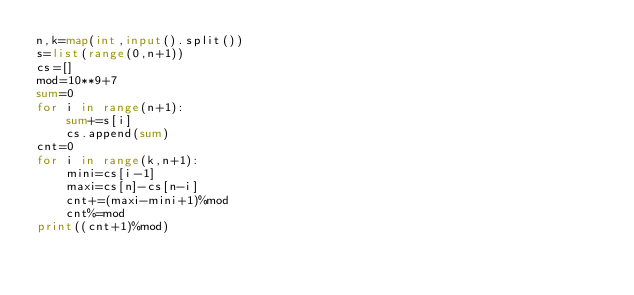<code> <loc_0><loc_0><loc_500><loc_500><_Python_>n,k=map(int,input().split())
s=list(range(0,n+1))
cs=[]
mod=10**9+7
sum=0
for i in range(n+1):
	sum+=s[i]
	cs.append(sum)
cnt=0
for i in range(k,n+1):
	mini=cs[i-1]
	maxi=cs[n]-cs[n-i]
	cnt+=(maxi-mini+1)%mod
	cnt%=mod
print((cnt+1)%mod)</code> 